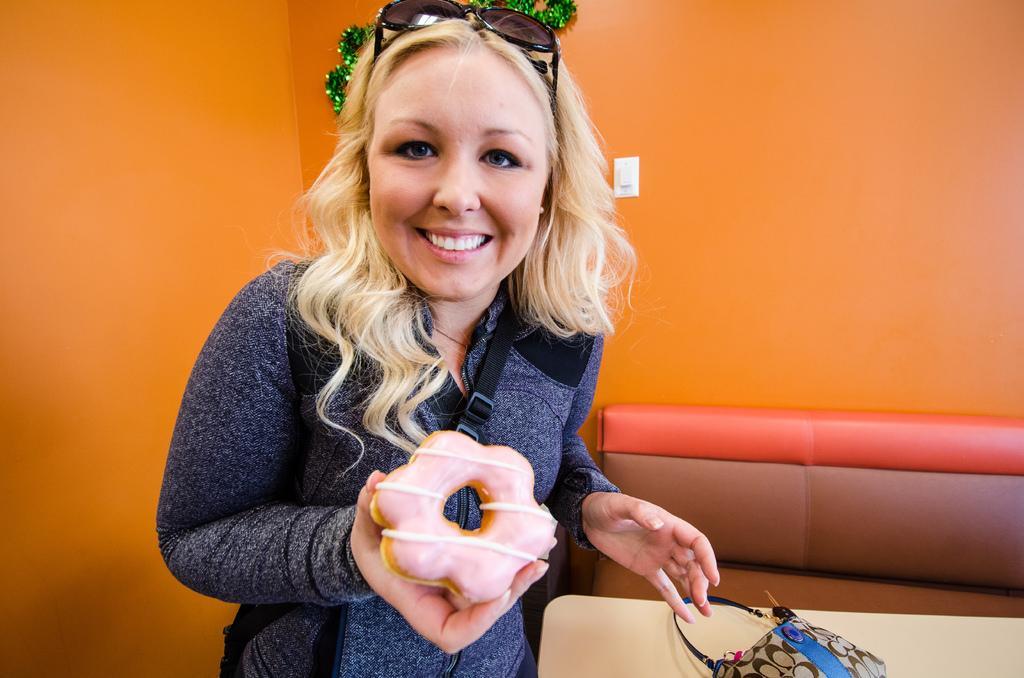In one or two sentences, can you explain what this image depicts? In this image there is a girl standing with a smile on her face and she is holding a food item in her hand, inside her there is a table with a handbag on top of it, in front of that there is a sofa. In the background there is a wall. 